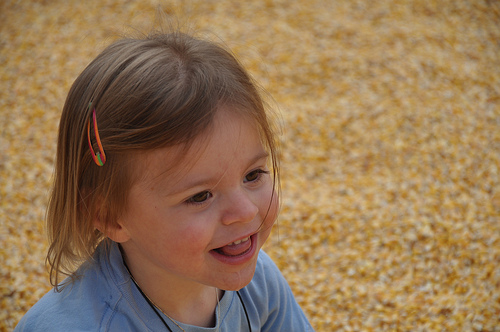<image>
Is the hair clip next to the field? No. The hair clip is not positioned next to the field. They are located in different areas of the scene. 